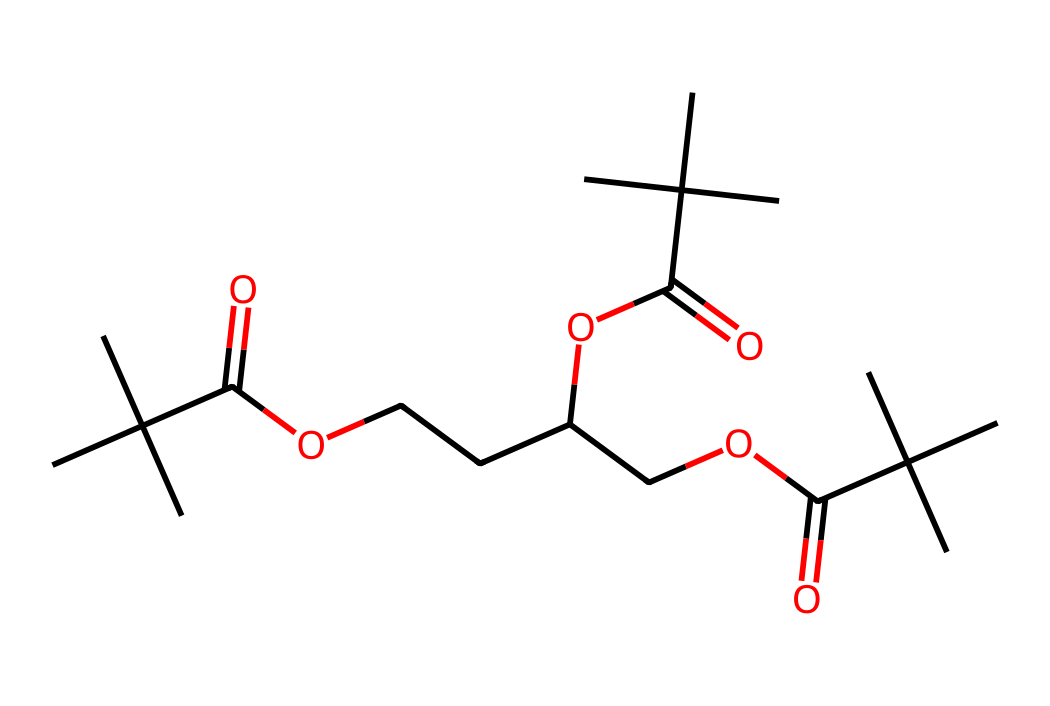What is the molecular formula of this compound? To determine the molecular formula, you need to count the number of carbon (C), hydrogen (H), and oxygen (O) atoms in the SMILES representation. The chemical structure contains numerous branching points and functional groups. After analyzing, we find there are 24 carbon atoms, 46 hydrogen atoms, and 6 oxygen atoms. Therefore, the molecular formula is C24H46O6.
Answer: C24H46O6 How many ester functional groups are present? When analyzing the structure, an ester functional group is identified by the presence of a carbon atom double bonded to an oxygen atom and single bonded to another oxygen atom which is further connected to another carbon. There appear to be three ester groups from the structure as we can see three occurrences of this formation.
Answer: 3 What basic function does the acetyl group serve in this structure? The acetyl group facilitates the polymer's ability to undergo shape memory effects. The presence of acetyl groups in polymer chains contributes to the flexibility and thermal properties, which are crucial for self-adjusting applications in VR accessories.
Answer: flexibility What type of polymer is represented by this structure? Upon examining the chemical architecture, this compound is a type of shape-memory polymer, characterized by its ability to return to a predefined shape upon exposure to a stimulus such as heat. This property renders it suitable for adaptable and self-adjusting applications in VR technologies.
Answer: shape-memory polymer How many distinct repeating units can be identified in the polymer structure? In the polymer structure, you can distinguish several repeating units due to the branched nature of the compound. By evaluating the symmetry and the similar arrangements of functional groups, there are essentially three distinct repeating units identified, each contributing to the overall properties of the polymer.
Answer: 3 